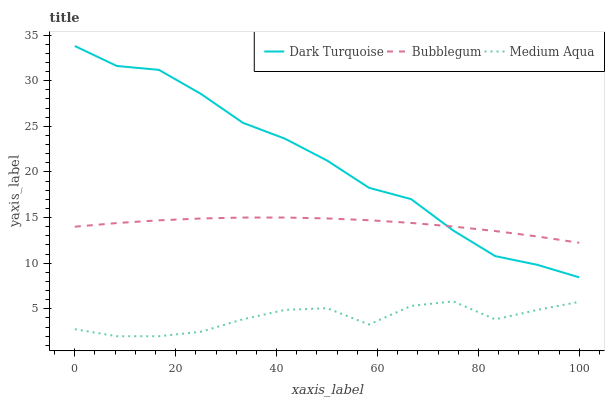Does Medium Aqua have the minimum area under the curve?
Answer yes or no. Yes. Does Dark Turquoise have the maximum area under the curve?
Answer yes or no. Yes. Does Bubblegum have the minimum area under the curve?
Answer yes or no. No. Does Bubblegum have the maximum area under the curve?
Answer yes or no. No. Is Bubblegum the smoothest?
Answer yes or no. Yes. Is Medium Aqua the roughest?
Answer yes or no. Yes. Is Medium Aqua the smoothest?
Answer yes or no. No. Is Bubblegum the roughest?
Answer yes or no. No. Does Medium Aqua have the lowest value?
Answer yes or no. Yes. Does Bubblegum have the lowest value?
Answer yes or no. No. Does Dark Turquoise have the highest value?
Answer yes or no. Yes. Does Bubblegum have the highest value?
Answer yes or no. No. Is Medium Aqua less than Bubblegum?
Answer yes or no. Yes. Is Dark Turquoise greater than Medium Aqua?
Answer yes or no. Yes. Does Dark Turquoise intersect Bubblegum?
Answer yes or no. Yes. Is Dark Turquoise less than Bubblegum?
Answer yes or no. No. Is Dark Turquoise greater than Bubblegum?
Answer yes or no. No. Does Medium Aqua intersect Bubblegum?
Answer yes or no. No. 